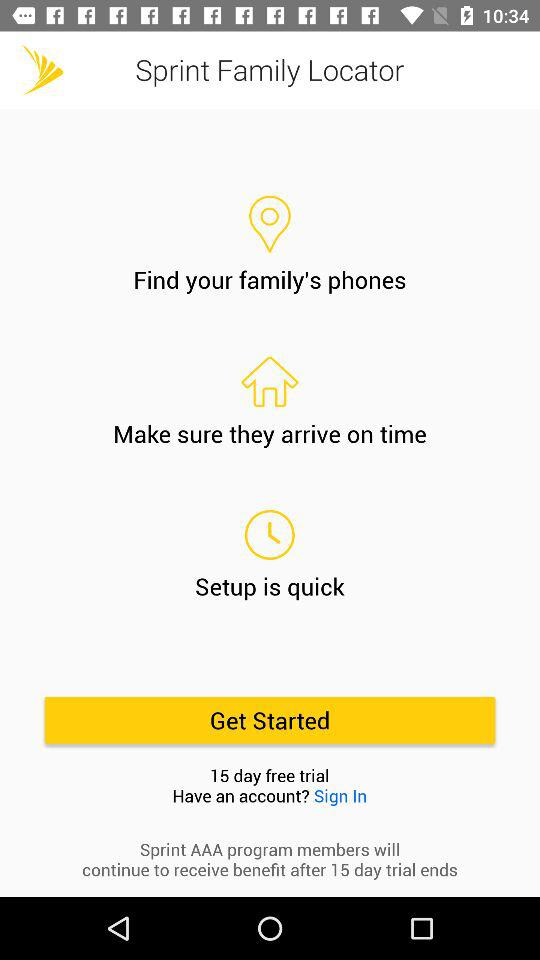What is the application name? The application name is "Sprint Family Locator". 